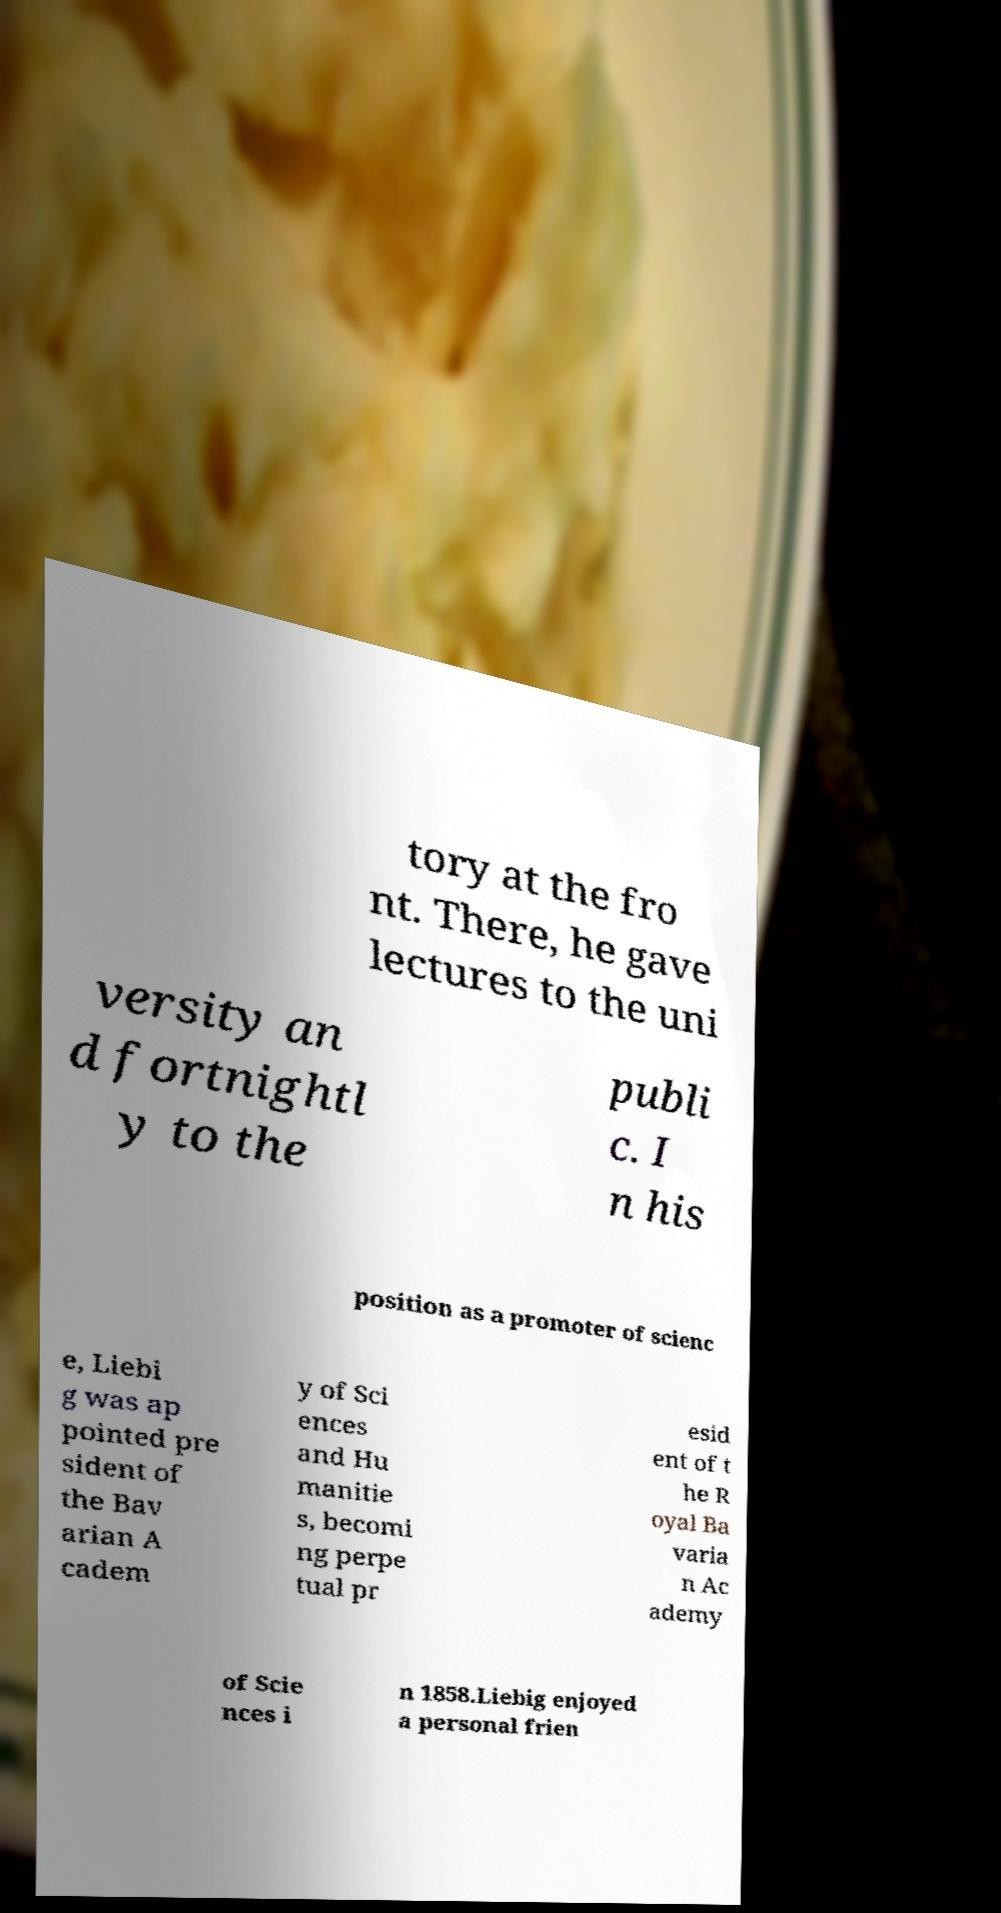There's text embedded in this image that I need extracted. Can you transcribe it verbatim? tory at the fro nt. There, he gave lectures to the uni versity an d fortnightl y to the publi c. I n his position as a promoter of scienc e, Liebi g was ap pointed pre sident of the Bav arian A cadem y of Sci ences and Hu manitie s, becomi ng perpe tual pr esid ent of t he R oyal Ba varia n Ac ademy of Scie nces i n 1858.Liebig enjoyed a personal frien 